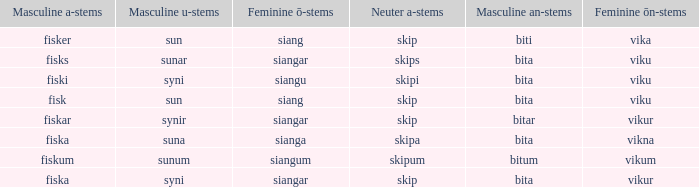What is the u form of the word with a neuter form of skip and a masculine a-ending of fisker? Sun. Could you help me parse every detail presented in this table? {'header': ['Masculine a-stems', 'Masculine u-stems', 'Feminine ō-stems', 'Neuter a-stems', 'Masculine an-stems', 'Feminine ōn-stems'], 'rows': [['fisker', 'sun', 'siang', 'skip', 'biti', 'vika'], ['fisks', 'sunar', 'siangar', 'skips', 'bita', 'viku'], ['fiski', 'syni', 'siangu', 'skipi', 'bita', 'viku'], ['fisk', 'sun', 'siang', 'skip', 'bita', 'viku'], ['fiskar', 'synir', 'siangar', 'skip', 'bitar', 'vikur'], ['fiska', 'suna', 'sianga', 'skipa', 'bita', 'vikna'], ['fiskum', 'sunum', 'siangum', 'skipum', 'bitum', 'vikum'], ['fiska', 'syni', 'siangar', 'skip', 'bita', 'vikur']]} 